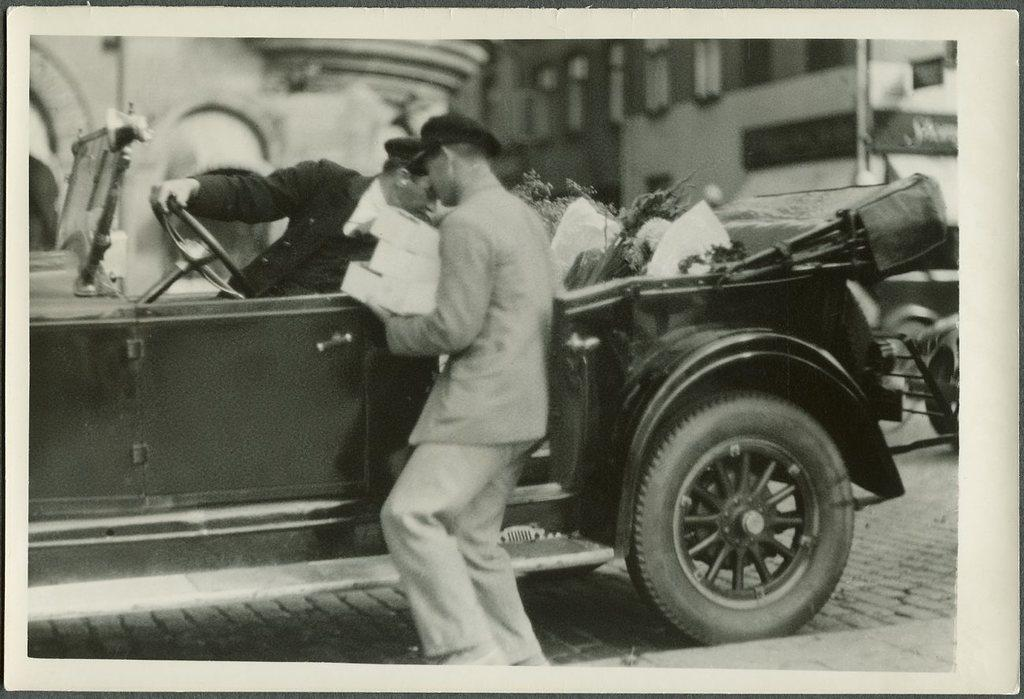What is the color scheme of the image? The image is black and white. What can be seen in the image? There is a vehicle in the image. How many people are present in the image? One person is sitting inside the vehicle, and another person is standing outside the vehicle. What is visible in the background of the image? There are buildings visible in the background. What type of record is being played by the person standing outside the vehicle? There is no record or music player visible in the image, so it cannot be determined if any records are being played. 